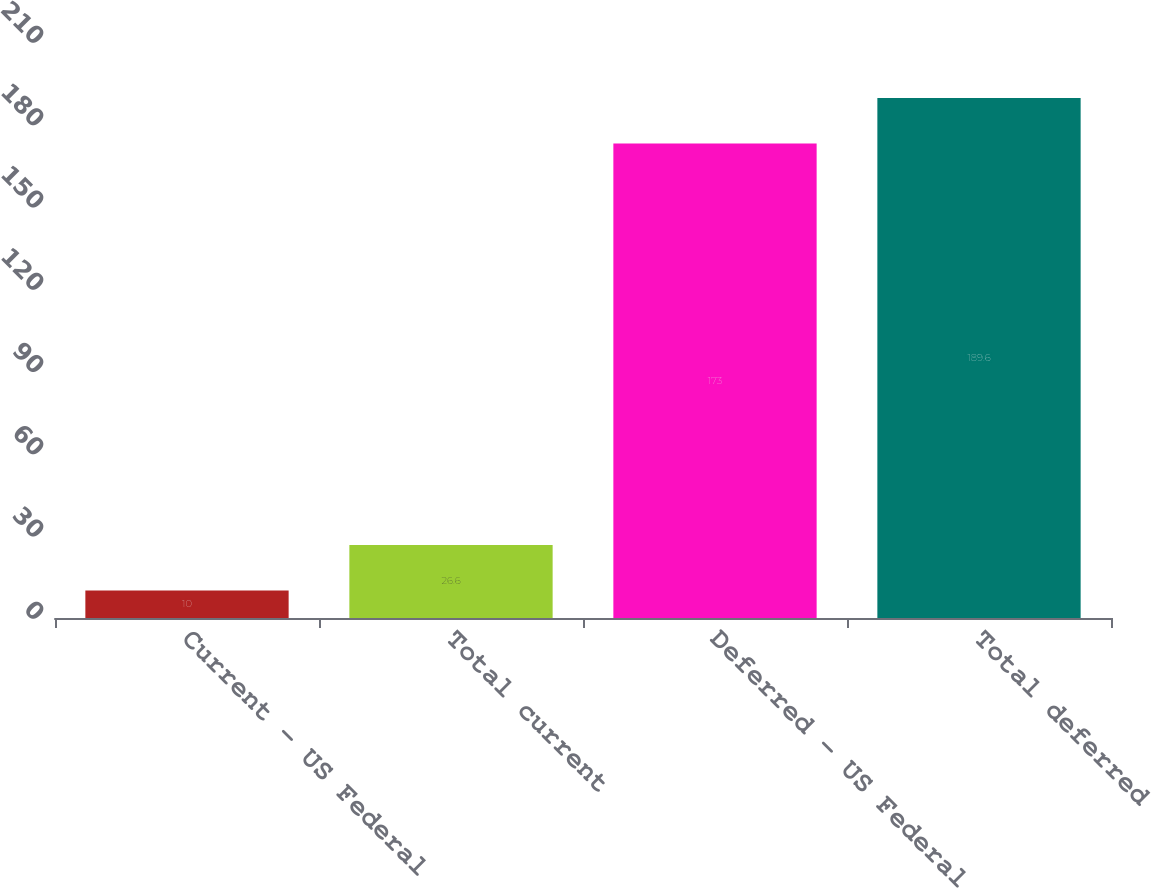Convert chart to OTSL. <chart><loc_0><loc_0><loc_500><loc_500><bar_chart><fcel>Current - US Federal<fcel>Total current<fcel>Deferred - US Federal<fcel>Total deferred<nl><fcel>10<fcel>26.6<fcel>173<fcel>189.6<nl></chart> 